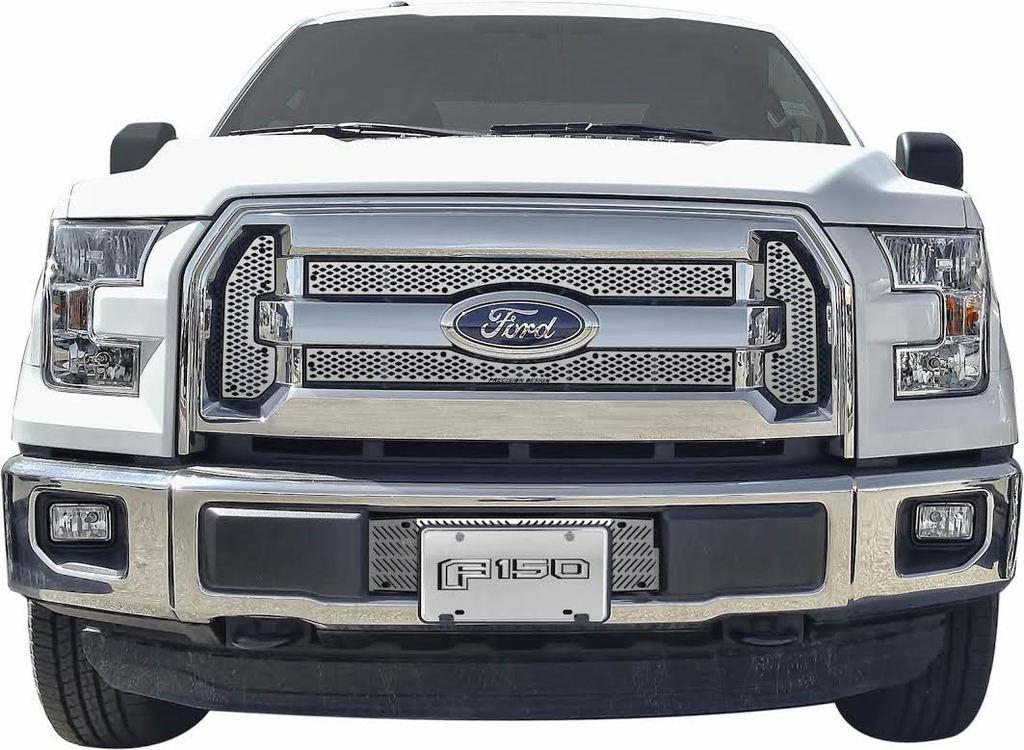What is the main subject of the image? There is a car in the image. What color is the background of the image? The background of the image is white. How many rocks can be seen on the calculator in the image? There is no calculator or rocks present in the image; it features a car with a white background. 